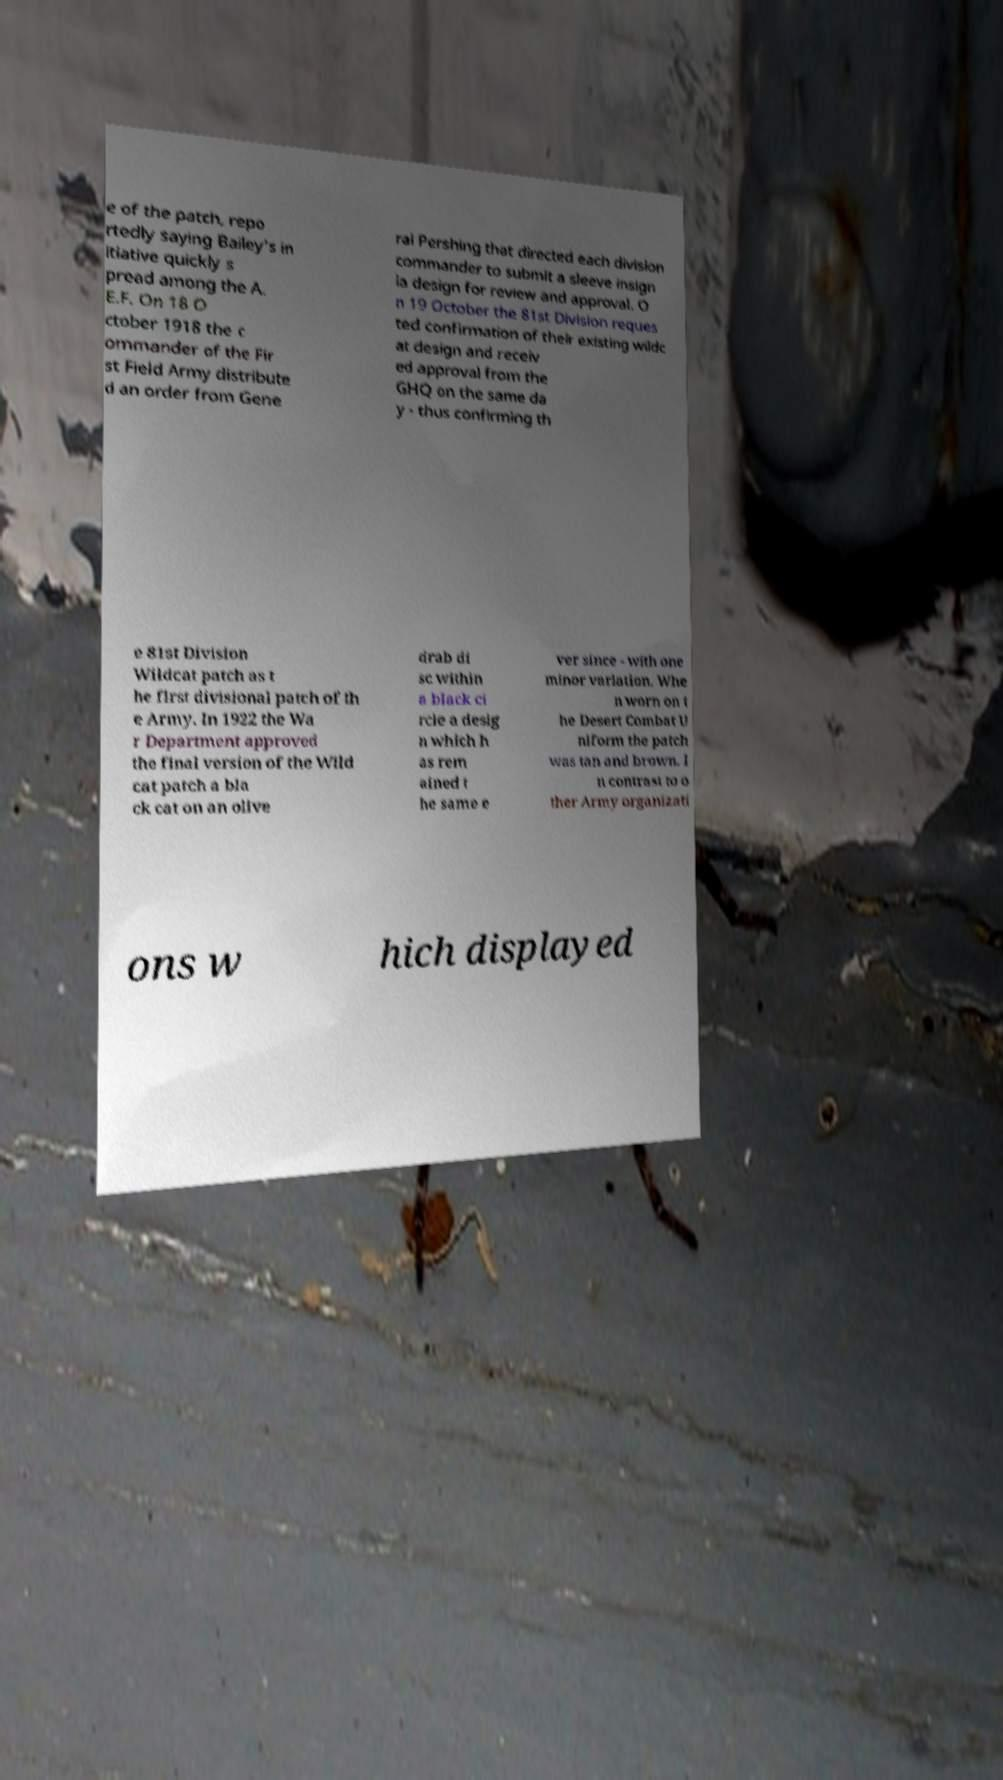Please identify and transcribe the text found in this image. e of the patch, repo rtedly saying Bailey's in itiative quickly s pread among the A. E.F. On 18 O ctober 1918 the c ommander of the Fir st Field Army distribute d an order from Gene ral Pershing that directed each division commander to submit a sleeve insign ia design for review and approval. O n 19 October the 81st Division reques ted confirmation of their existing wildc at design and receiv ed approval from the GHQ on the same da y - thus confirming th e 81st Division Wildcat patch as t he first divisional patch of th e Army. In 1922 the Wa r Department approved the final version of the Wild cat patch a bla ck cat on an olive drab di sc within a black ci rcle a desig n which h as rem ained t he same e ver since - with one minor variation. Whe n worn on t he Desert Combat U niform the patch was tan and brown. I n contrast to o ther Army organizati ons w hich displayed 